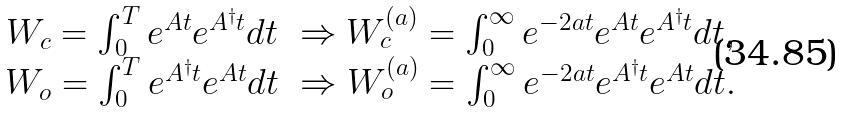<formula> <loc_0><loc_0><loc_500><loc_500>\begin{array} { c } W _ { c } = \int _ { 0 } ^ { T } e ^ { A t } e ^ { A ^ { \dagger } t } d t \ \Rightarrow W _ { c } ^ { ( a ) } = \int _ { 0 } ^ { \infty } e ^ { - 2 a t } e ^ { A t } e ^ { A ^ { \dagger } t } d t , \\ W _ { o } = \int _ { 0 } ^ { T } e ^ { A ^ { \dagger } t } e ^ { A t } d t \ \Rightarrow W _ { o } ^ { ( a ) } = \int _ { 0 } ^ { \infty } e ^ { - 2 a t } e ^ { A ^ { \dagger } t } e ^ { A t } d t . \end{array}</formula> 